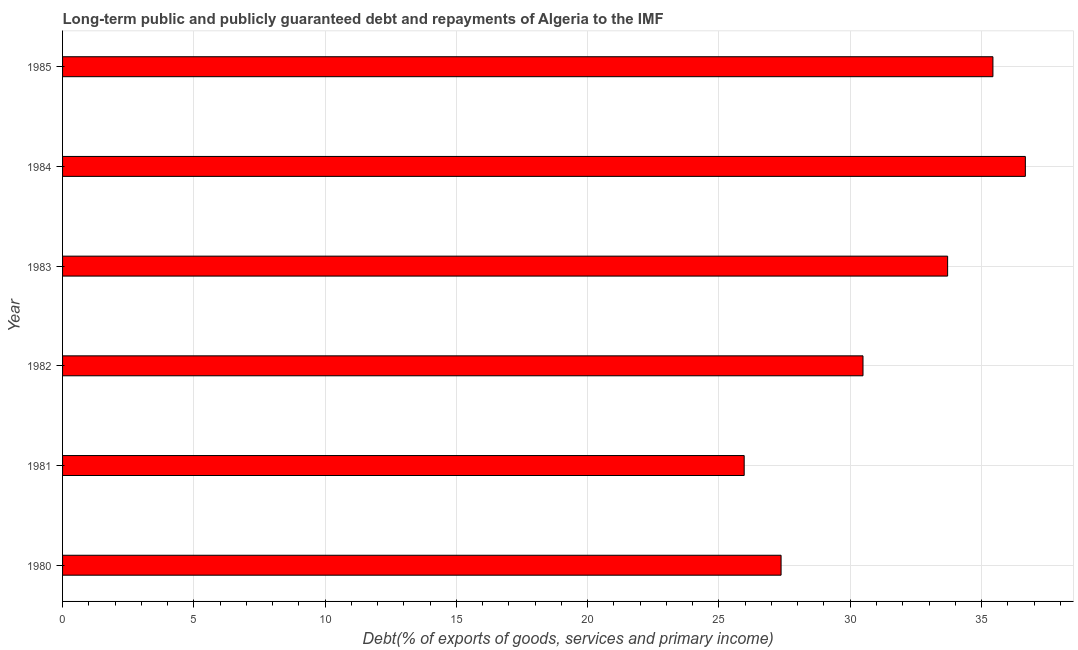Does the graph contain any zero values?
Provide a succinct answer. No. Does the graph contain grids?
Your answer should be very brief. Yes. What is the title of the graph?
Ensure brevity in your answer.  Long-term public and publicly guaranteed debt and repayments of Algeria to the IMF. What is the label or title of the X-axis?
Ensure brevity in your answer.  Debt(% of exports of goods, services and primary income). What is the debt service in 1981?
Your answer should be compact. 25.96. Across all years, what is the maximum debt service?
Keep it short and to the point. 36.67. Across all years, what is the minimum debt service?
Your response must be concise. 25.96. In which year was the debt service maximum?
Your answer should be very brief. 1984. In which year was the debt service minimum?
Keep it short and to the point. 1981. What is the sum of the debt service?
Make the answer very short. 189.62. What is the difference between the debt service in 1980 and 1983?
Provide a succinct answer. -6.34. What is the average debt service per year?
Offer a terse response. 31.6. What is the median debt service?
Offer a very short reply. 32.1. In how many years, is the debt service greater than 30 %?
Offer a terse response. 4. What is the ratio of the debt service in 1983 to that in 1985?
Your response must be concise. 0.95. Is the debt service in 1981 less than that in 1985?
Provide a short and direct response. Yes. Is the difference between the debt service in 1980 and 1985 greater than the difference between any two years?
Provide a succinct answer. No. What is the difference between the highest and the second highest debt service?
Keep it short and to the point. 1.24. What is the difference between the highest and the lowest debt service?
Give a very brief answer. 10.71. How many bars are there?
Your answer should be compact. 6. Are the values on the major ticks of X-axis written in scientific E-notation?
Your answer should be compact. No. What is the Debt(% of exports of goods, services and primary income) of 1980?
Ensure brevity in your answer.  27.37. What is the Debt(% of exports of goods, services and primary income) in 1981?
Offer a terse response. 25.96. What is the Debt(% of exports of goods, services and primary income) in 1982?
Offer a very short reply. 30.49. What is the Debt(% of exports of goods, services and primary income) of 1983?
Your answer should be very brief. 33.71. What is the Debt(% of exports of goods, services and primary income) of 1984?
Make the answer very short. 36.67. What is the Debt(% of exports of goods, services and primary income) of 1985?
Make the answer very short. 35.43. What is the difference between the Debt(% of exports of goods, services and primary income) in 1980 and 1981?
Ensure brevity in your answer.  1.4. What is the difference between the Debt(% of exports of goods, services and primary income) in 1980 and 1982?
Give a very brief answer. -3.12. What is the difference between the Debt(% of exports of goods, services and primary income) in 1980 and 1983?
Provide a succinct answer. -6.34. What is the difference between the Debt(% of exports of goods, services and primary income) in 1980 and 1984?
Give a very brief answer. -9.3. What is the difference between the Debt(% of exports of goods, services and primary income) in 1980 and 1985?
Provide a succinct answer. -8.07. What is the difference between the Debt(% of exports of goods, services and primary income) in 1981 and 1982?
Provide a short and direct response. -4.52. What is the difference between the Debt(% of exports of goods, services and primary income) in 1981 and 1983?
Your answer should be very brief. -7.75. What is the difference between the Debt(% of exports of goods, services and primary income) in 1981 and 1984?
Provide a short and direct response. -10.71. What is the difference between the Debt(% of exports of goods, services and primary income) in 1981 and 1985?
Your response must be concise. -9.47. What is the difference between the Debt(% of exports of goods, services and primary income) in 1982 and 1983?
Make the answer very short. -3.22. What is the difference between the Debt(% of exports of goods, services and primary income) in 1982 and 1984?
Give a very brief answer. -6.18. What is the difference between the Debt(% of exports of goods, services and primary income) in 1982 and 1985?
Ensure brevity in your answer.  -4.95. What is the difference between the Debt(% of exports of goods, services and primary income) in 1983 and 1984?
Make the answer very short. -2.96. What is the difference between the Debt(% of exports of goods, services and primary income) in 1983 and 1985?
Your answer should be compact. -1.73. What is the difference between the Debt(% of exports of goods, services and primary income) in 1984 and 1985?
Offer a terse response. 1.24. What is the ratio of the Debt(% of exports of goods, services and primary income) in 1980 to that in 1981?
Your answer should be very brief. 1.05. What is the ratio of the Debt(% of exports of goods, services and primary income) in 1980 to that in 1982?
Offer a terse response. 0.9. What is the ratio of the Debt(% of exports of goods, services and primary income) in 1980 to that in 1983?
Give a very brief answer. 0.81. What is the ratio of the Debt(% of exports of goods, services and primary income) in 1980 to that in 1984?
Offer a very short reply. 0.75. What is the ratio of the Debt(% of exports of goods, services and primary income) in 1980 to that in 1985?
Ensure brevity in your answer.  0.77. What is the ratio of the Debt(% of exports of goods, services and primary income) in 1981 to that in 1982?
Provide a succinct answer. 0.85. What is the ratio of the Debt(% of exports of goods, services and primary income) in 1981 to that in 1983?
Provide a short and direct response. 0.77. What is the ratio of the Debt(% of exports of goods, services and primary income) in 1981 to that in 1984?
Provide a succinct answer. 0.71. What is the ratio of the Debt(% of exports of goods, services and primary income) in 1981 to that in 1985?
Keep it short and to the point. 0.73. What is the ratio of the Debt(% of exports of goods, services and primary income) in 1982 to that in 1983?
Offer a very short reply. 0.9. What is the ratio of the Debt(% of exports of goods, services and primary income) in 1982 to that in 1984?
Provide a short and direct response. 0.83. What is the ratio of the Debt(% of exports of goods, services and primary income) in 1982 to that in 1985?
Give a very brief answer. 0.86. What is the ratio of the Debt(% of exports of goods, services and primary income) in 1983 to that in 1984?
Offer a very short reply. 0.92. What is the ratio of the Debt(% of exports of goods, services and primary income) in 1983 to that in 1985?
Ensure brevity in your answer.  0.95. What is the ratio of the Debt(% of exports of goods, services and primary income) in 1984 to that in 1985?
Provide a short and direct response. 1.03. 